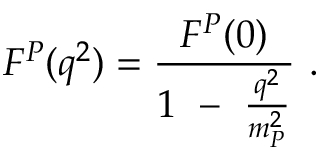<formula> <loc_0><loc_0><loc_500><loc_500>F ^ { P } ( q ^ { 2 } ) = \frac { F ^ { P } ( 0 ) } { 1 - \frac { q ^ { 2 } } { m _ { P } ^ { 2 } } } .</formula> 